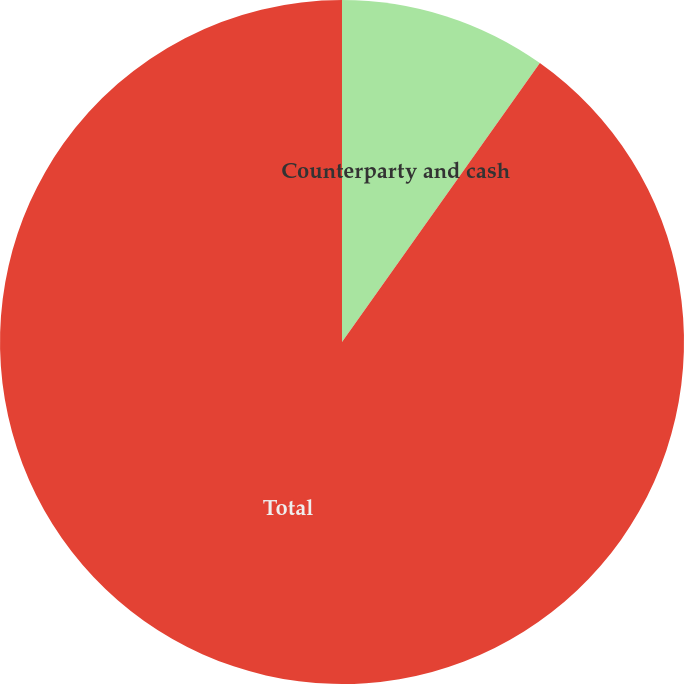Convert chart. <chart><loc_0><loc_0><loc_500><loc_500><pie_chart><fcel>Counterparty and cash<fcel>Total<nl><fcel>9.82%<fcel>90.18%<nl></chart> 